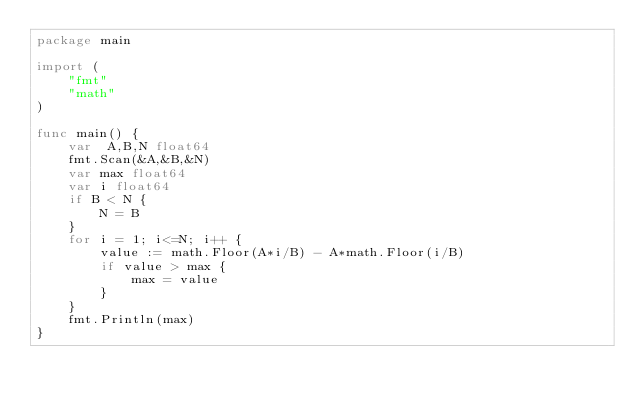Convert code to text. <code><loc_0><loc_0><loc_500><loc_500><_Go_>package main

import (
	"fmt"
	"math"
)

func main() {
	var  A,B,N float64
	fmt.Scan(&A,&B,&N)
	var max float64
	var i float64
	if B < N {
		N = B
	}
	for i = 1; i<=N; i++ {
		value := math.Floor(A*i/B) - A*math.Floor(i/B)
		if value > max {
			max = value
		}
	}
	fmt.Println(max)
}</code> 